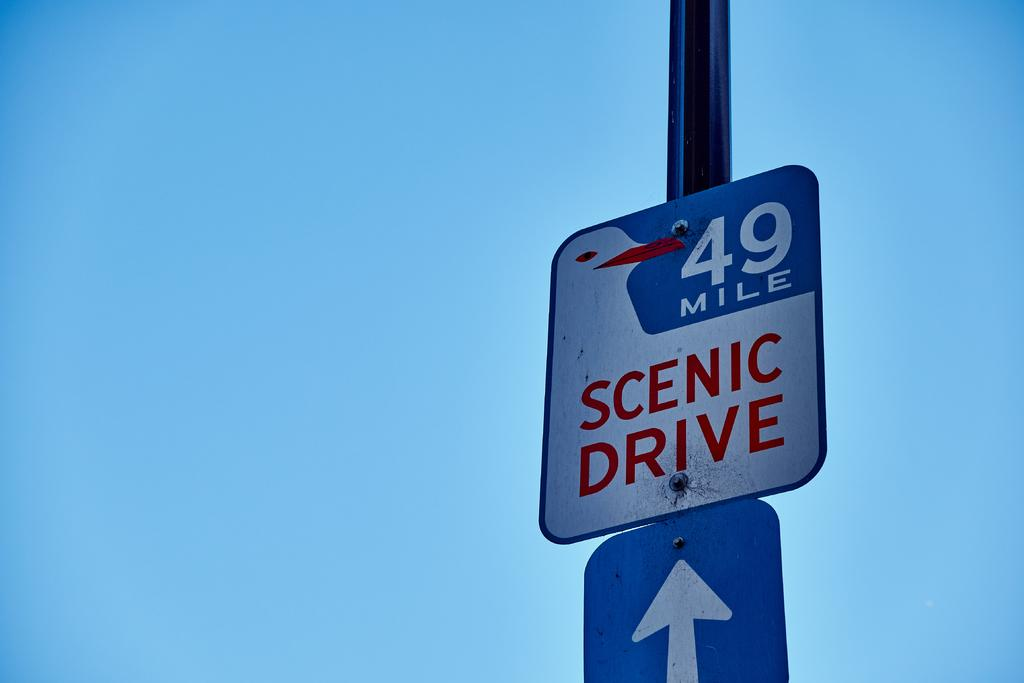<image>
Offer a succinct explanation of the picture presented. A street sign stating 49 mile and scenic drive is on a pole above a sign with a white arrow pointing up 